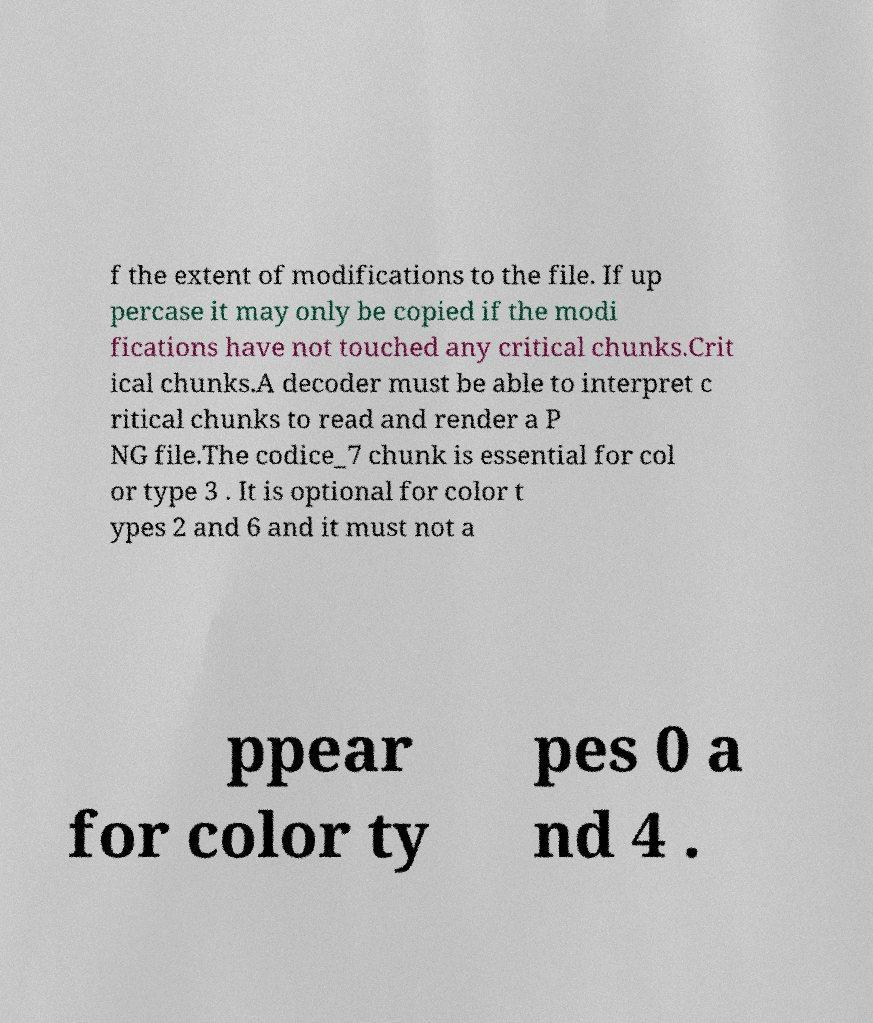Please read and relay the text visible in this image. What does it say? f the extent of modifications to the file. If up percase it may only be copied if the modi fications have not touched any critical chunks.Crit ical chunks.A decoder must be able to interpret c ritical chunks to read and render a P NG file.The codice_7 chunk is essential for col or type 3 . It is optional for color t ypes 2 and 6 and it must not a ppear for color ty pes 0 a nd 4 . 